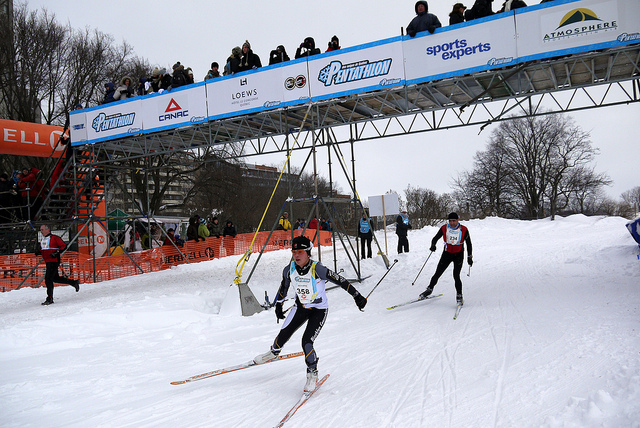Please transcribe the text information in this image. PENTATHLON CANAC LOEWS PENTATHLON sports 258 ATMOSPHERE ATMOSPHERE experts ELL 